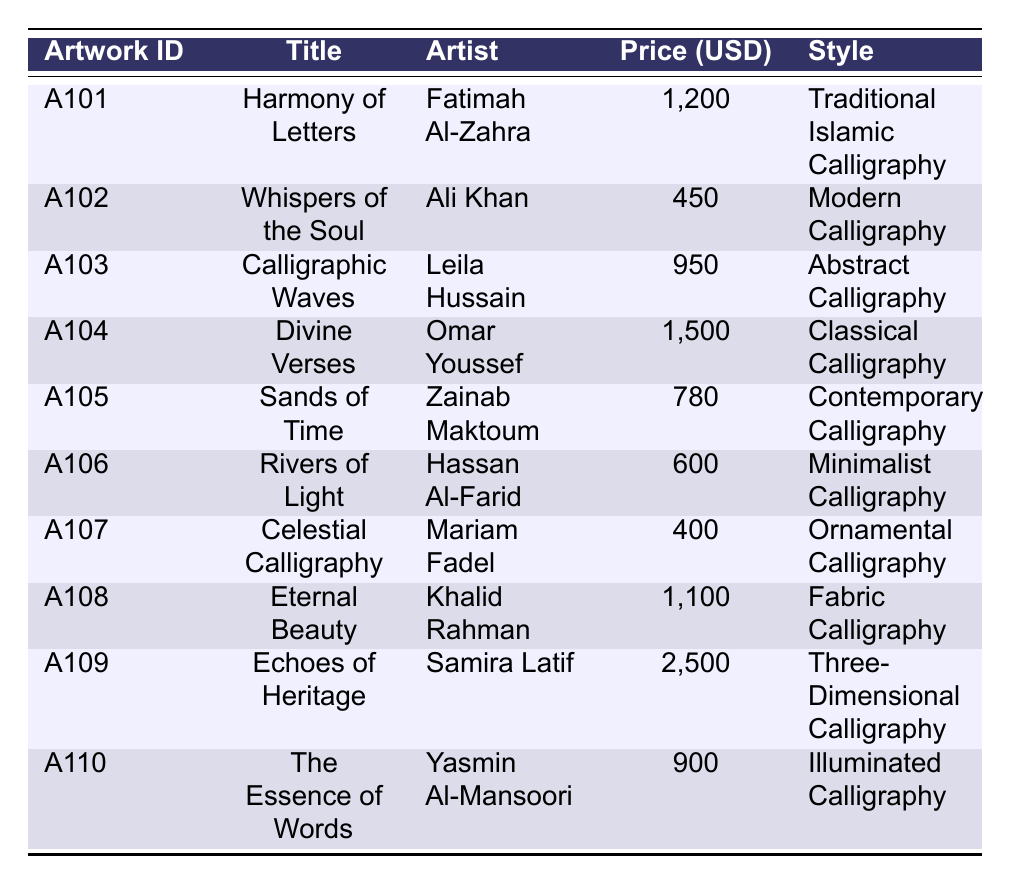What is the price of "Echoes of Heritage"? The artwork "Echoes of Heritage" is located in the row with the title in the table. By looking at the Price column for this artwork, we find that it is listed at 2500 USD.
Answer: 2500 USD Who is the artist of "Sands of Time"? Locating "Sands of Time" in the table allows us to check the Artist column, where we see that Zainab Maktoum is listed as its artist.
Answer: Zainab Maktoum What is the total price of all the artworks sold? We need to sum up the prices of each artwork in the Price column: 1200 + 450 + 950 + 1500 + 780 + 600 + 400 + 1100 + 2500 + 900 = 9,580. Thus, the total sales amount is 9,580 USD.
Answer: 9580 USD How many artworks sold for more than 1000 USD? By examining the Price column, the artworks priced above 1000 USD are "Harmony of Letters", "Divine Verses", "Eternal Beauty", and "Echoes of Heritage" (4 artworks total).
Answer: 4 Is "Rivers of Light" a digital artwork? Looking at the medium used for "Rivers of Light" in the table, we see that it is categorized as "Digital Art", confirming that the statement is true.
Answer: Yes Which style had the highest-priced artwork? To find the style of the highest-priced artwork "Echoes of Heritage," we check the Price column and find it priced at 2500 USD. The corresponding style listed is "Three-Dimensional Calligraphy."
Answer: Three-Dimensional Calligraphy 